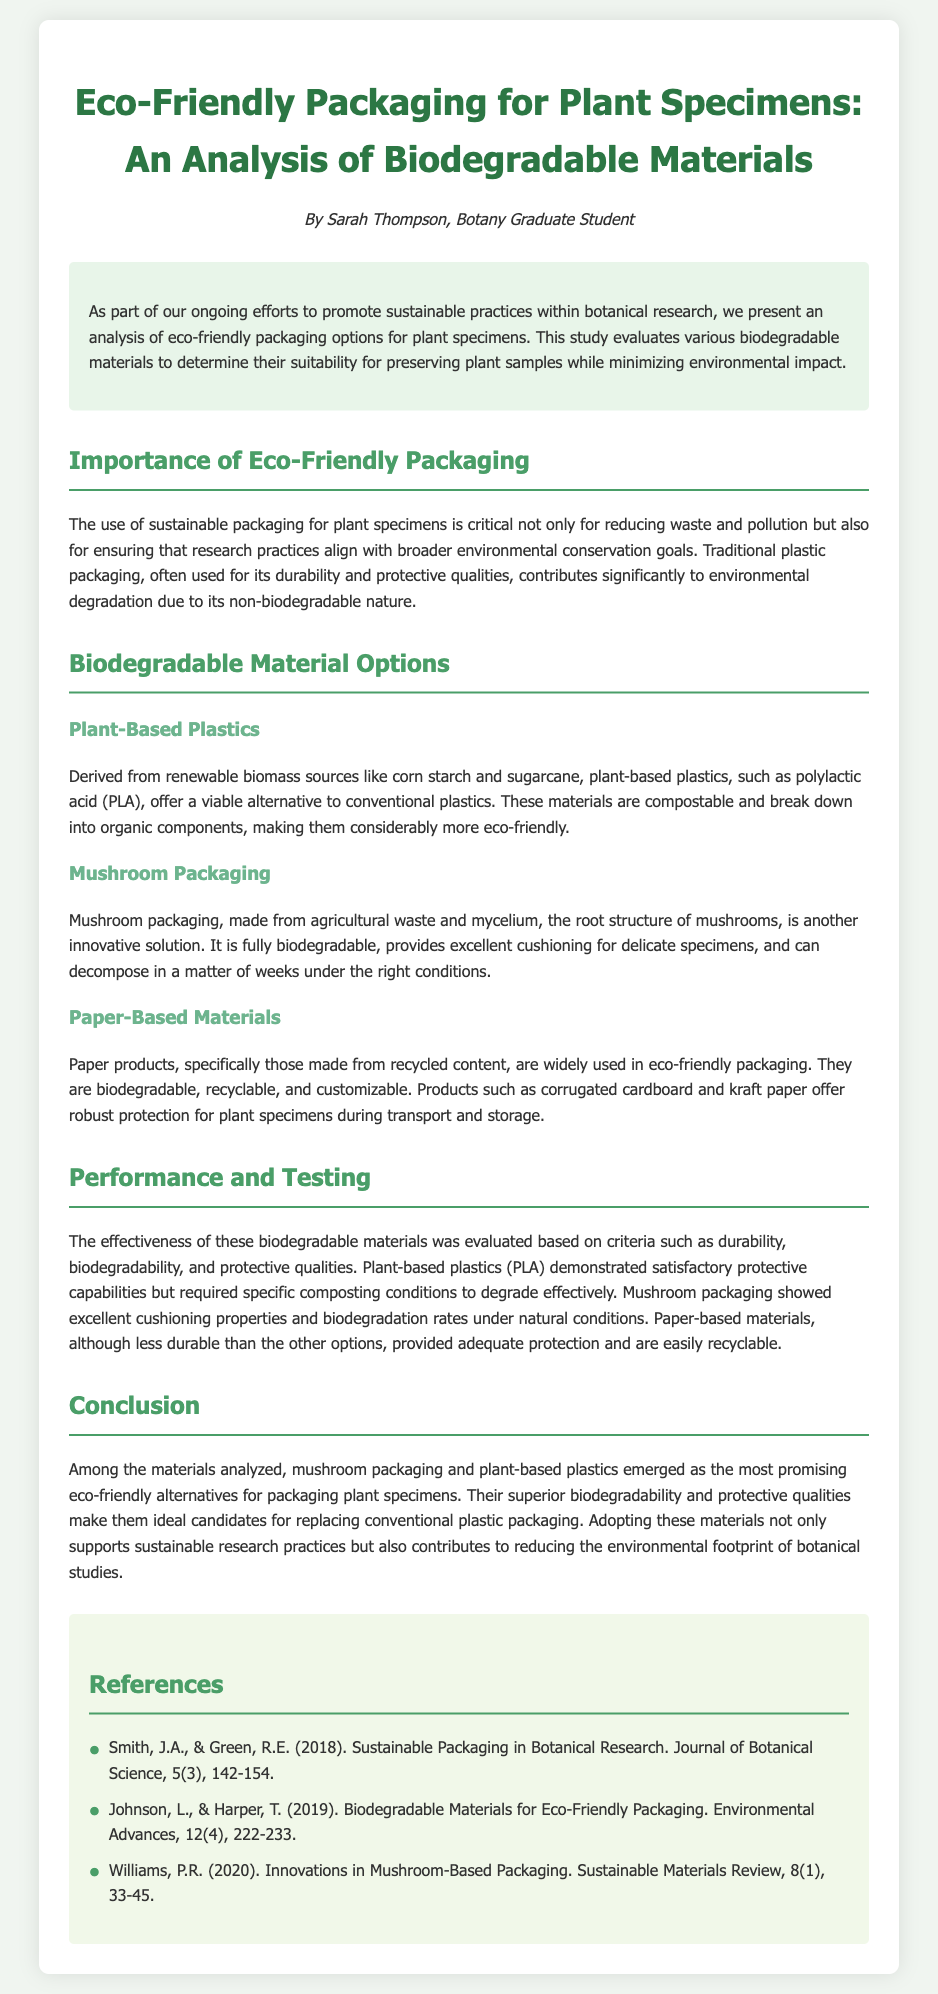what is the title of the document? The title of the document is presented in the header section and summarizes the content, which is focused on eco-friendly packaging for plant specimens.
Answer: Eco-Friendly Packaging for Plant Specimens: An Analysis of Biodegradable Materials who is the author of the document? The author’s name is listed below the title, indicating the individual responsible for the content.
Answer: Sarah Thompson what are the two most promising eco-friendly alternatives for packaging plant specimens? The document states the conclusion section highlights the top materials identified for this purpose, which were mentioned earlier in the text.
Answer: mushroom packaging and plant-based plastics what is one type of plant-based plastic mentioned? The document lists specific examples of plant-based plastics that are derived from renewable sources, providing an answer to this question.
Answer: polylactic acid (PLA) how does mushroom packaging decompose? The document explains the properties of mushroom packaging, including its decomposition under certain conditions.
Answer: in a matter of weeks what is one criterion used to evaluate biodegradable materials? The performance evaluation section outlines specific measures that were assessed during the analysis of materials.
Answer: durability what is the background color of the introduction section? The document describes the visual design and color themes used in the introduction area, which is distinct from other sections.
Answer: #e8f5e9 how many references are listed in the document? The references section concludes the document and counts the total number of cited sources for verification.
Answer: 3 